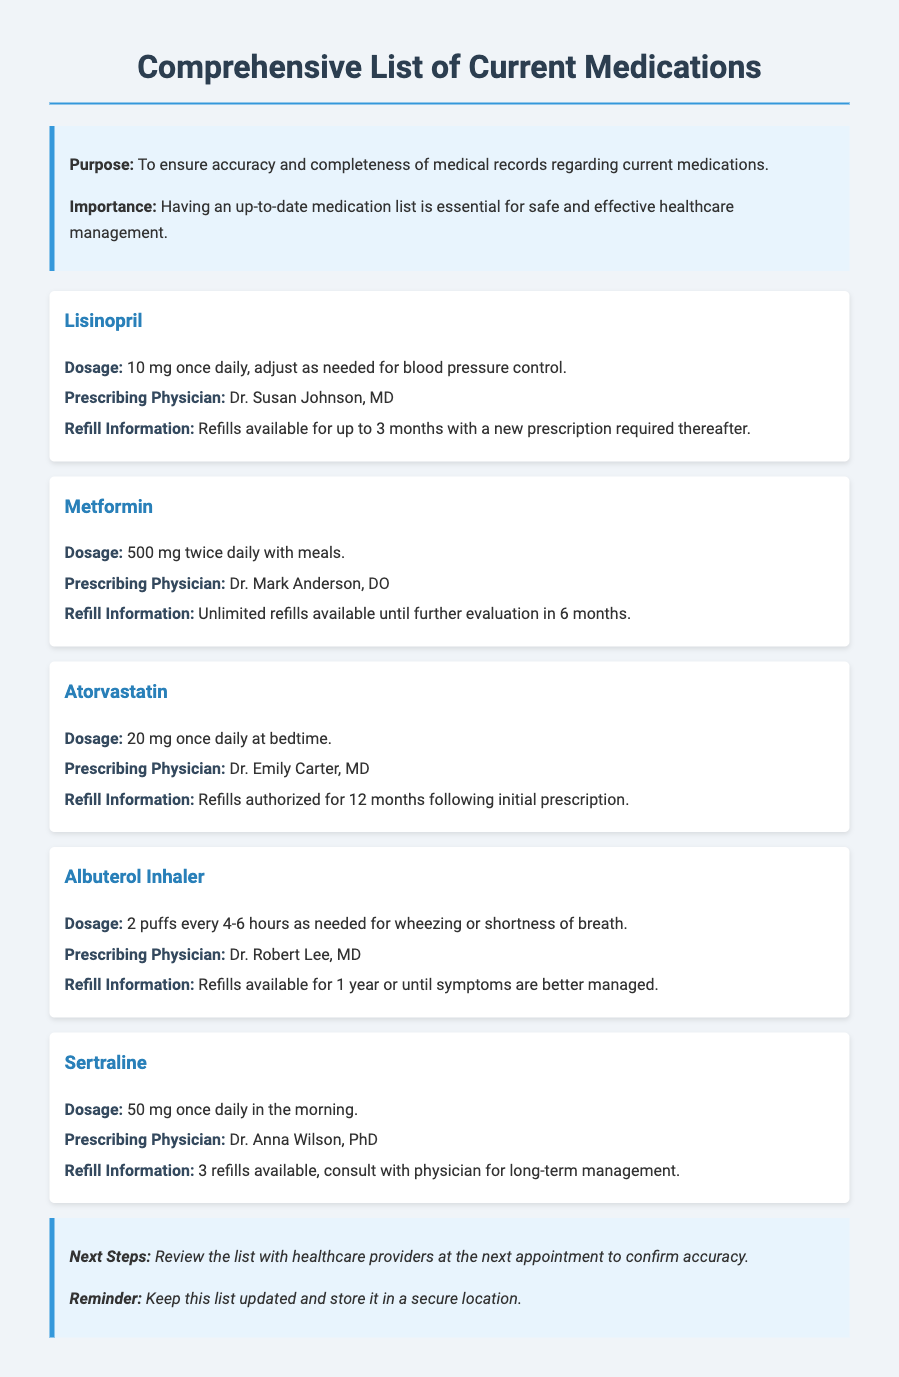What is the dosage for Lisinopril? The dosage for Lisinopril is 10 mg once daily, adjust as needed for blood pressure control.
Answer: 10 mg once daily Who is the prescribing physician for Metformin? The prescribing physician for Metformin is Dr. Mark Anderson, DO.
Answer: Dr. Mark Anderson, DO How many refills are available for Atorvastatin? Atorvastatin has refills authorized for 12 months following the initial prescription.
Answer: 12 months What is the prescribed dosage for Albuterol Inhaler? The prescribed dosage for Albuterol Inhaler is 2 puffs every 4-6 hours as needed for wheezing or shortness of breath.
Answer: 2 puffs every 4-6 hours How many refills are available for Sertraline? There are 3 refills available for Sertraline, consult with physician for long-term management.
Answer: 3 refills What is the importance of having an up-to-date medication list? The up-to-date medication list is essential for safe and effective healthcare management.
Answer: Safe and effective healthcare management Who is the prescribing physician for Sertraline? The prescribing physician for Sertraline is Dr. Anna Wilson, PhD.
Answer: Dr. Anna Wilson, PhD What is the next step mentioned in the conclusion? The next step is to review the list with healthcare providers at the next appointment to confirm accuracy.
Answer: Review with healthcare providers What is the dosage for Metformin? The dosage for Metformin is 500 mg twice daily with meals.
Answer: 500 mg twice daily 